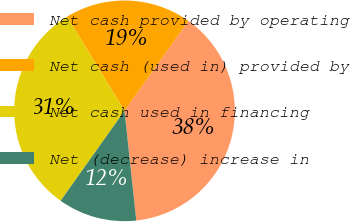<chart> <loc_0><loc_0><loc_500><loc_500><pie_chart><fcel>Net cash provided by operating<fcel>Net cash (used in) provided by<fcel>Net cash used in financing<fcel>Net (decrease) increase in<nl><fcel>38.47%<fcel>18.55%<fcel>31.45%<fcel>11.53%<nl></chart> 